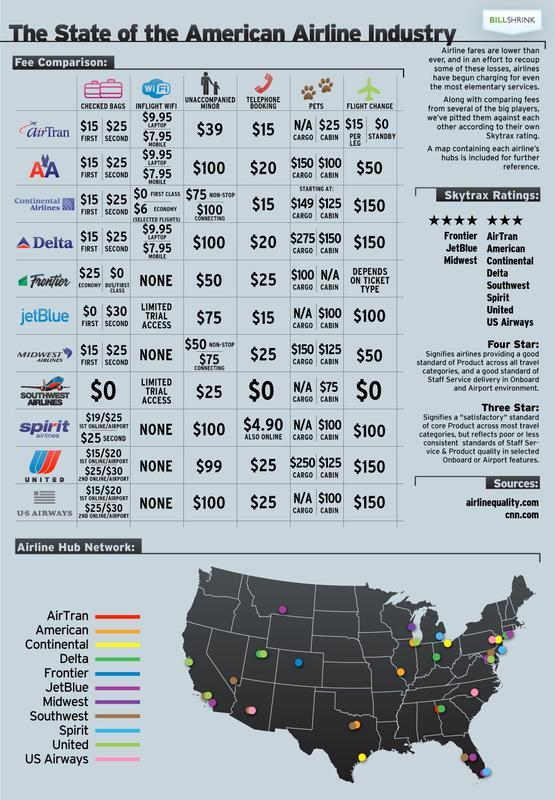Which airline has the lowest charge for unaccompanied minor?
Answer the question with a short phrase. Southwest Airlines How many airlines have None as fee for inflight wifi? 5 How much does Frontier airlines charge for carrying pets in cargo? $100 Which airline charges $0 for any flight changes? Southwest Airlines As per the given map, the number of airline hubs is lesser in which part of the country - Northwest or Northeast? Northwest Which airline charges $4.90 for telephone/online bookings? spirit airlines Which is the airline that charges $100 for unaccompanied minor AND $25 for telephone booking? US Airways How many airlines give Limited Trial Access for inflight Wifi? 2 